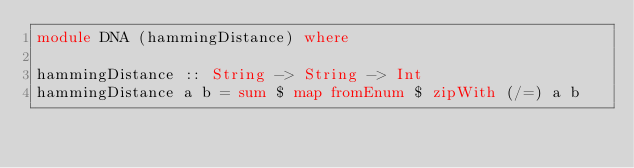<code> <loc_0><loc_0><loc_500><loc_500><_Haskell_>module DNA (hammingDistance) where

hammingDistance :: String -> String -> Int
hammingDistance a b = sum $ map fromEnum $ zipWith (/=) a b
</code> 